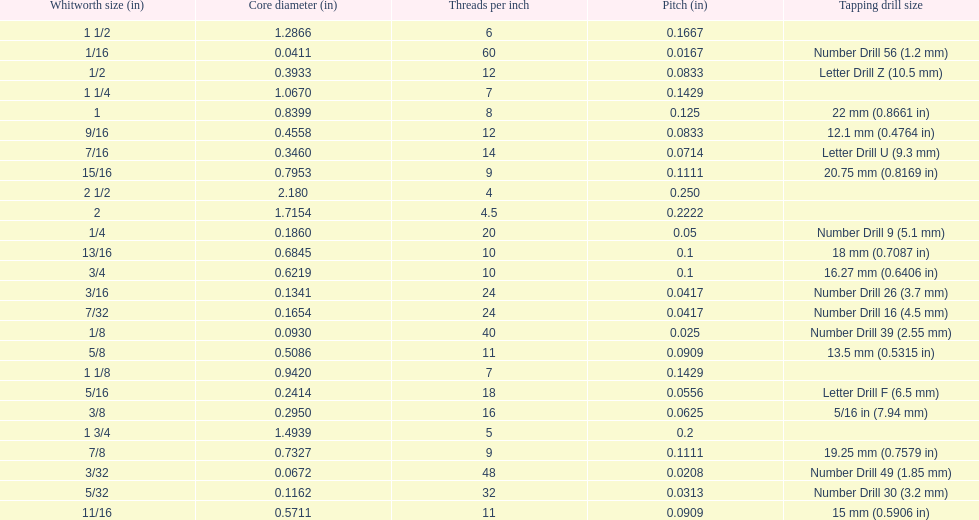How many threads per inch does a 9/16 have? 12. 